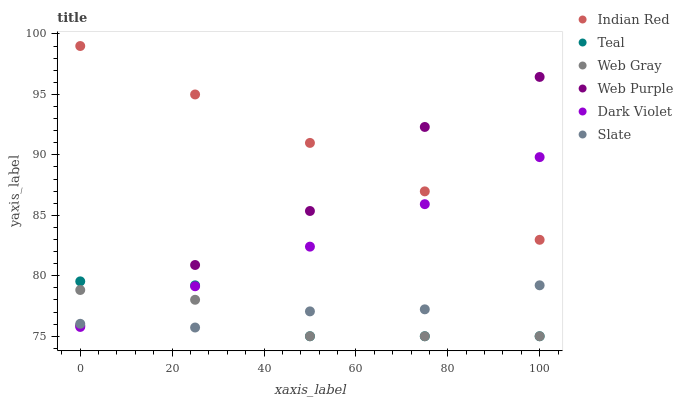Does Web Gray have the minimum area under the curve?
Answer yes or no. Yes. Does Indian Red have the maximum area under the curve?
Answer yes or no. Yes. Does Slate have the minimum area under the curve?
Answer yes or no. No. Does Slate have the maximum area under the curve?
Answer yes or no. No. Is Indian Red the smoothest?
Answer yes or no. Yes. Is Teal the roughest?
Answer yes or no. Yes. Is Slate the smoothest?
Answer yes or no. No. Is Slate the roughest?
Answer yes or no. No. Does Web Gray have the lowest value?
Answer yes or no. Yes. Does Slate have the lowest value?
Answer yes or no. No. Does Indian Red have the highest value?
Answer yes or no. Yes. Does Slate have the highest value?
Answer yes or no. No. Is Web Gray less than Indian Red?
Answer yes or no. Yes. Is Indian Red greater than Web Gray?
Answer yes or no. Yes. Does Teal intersect Dark Violet?
Answer yes or no. Yes. Is Teal less than Dark Violet?
Answer yes or no. No. Is Teal greater than Dark Violet?
Answer yes or no. No. Does Web Gray intersect Indian Red?
Answer yes or no. No. 